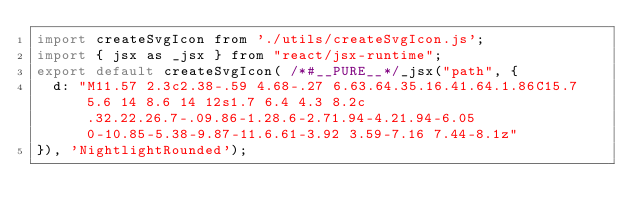Convert code to text. <code><loc_0><loc_0><loc_500><loc_500><_JavaScript_>import createSvgIcon from './utils/createSvgIcon.js';
import { jsx as _jsx } from "react/jsx-runtime";
export default createSvgIcon( /*#__PURE__*/_jsx("path", {
  d: "M11.57 2.3c2.38-.59 4.68-.27 6.63.64.35.16.41.64.1.86C15.7 5.6 14 8.6 14 12s1.7 6.4 4.3 8.2c.32.22.26.7-.09.86-1.28.6-2.71.94-4.21.94-6.05 0-10.85-5.38-9.87-11.6.61-3.92 3.59-7.16 7.44-8.1z"
}), 'NightlightRounded');</code> 